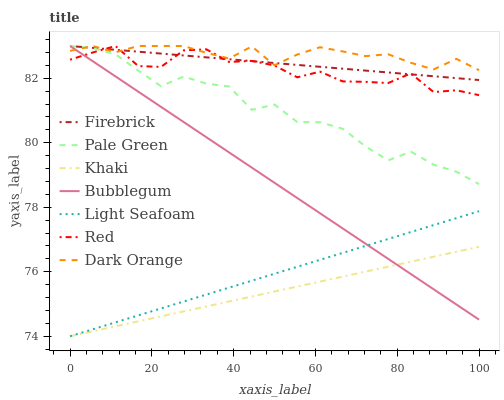Does Firebrick have the minimum area under the curve?
Answer yes or no. No. Does Firebrick have the maximum area under the curve?
Answer yes or no. No. Is Firebrick the smoothest?
Answer yes or no. No. Is Firebrick the roughest?
Answer yes or no. No. Does Firebrick have the lowest value?
Answer yes or no. No. Does Khaki have the highest value?
Answer yes or no. No. Is Khaki less than Red?
Answer yes or no. Yes. Is Firebrick greater than Khaki?
Answer yes or no. Yes. Does Khaki intersect Red?
Answer yes or no. No. 